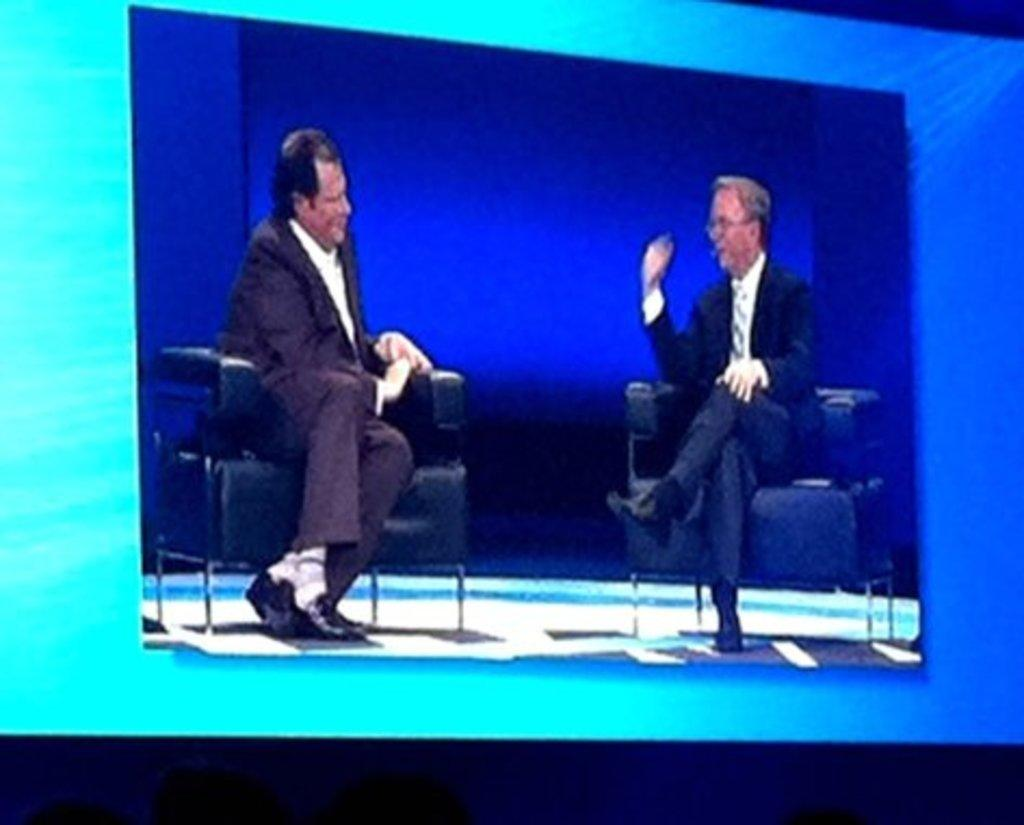What is the main object with a display in the image? There is a screen with a display in the image. How many people are present in the image? There are two men in the image. What are the two men doing in the image? The two men are sitting on chairs. What type of tank can be seen in the image? There is no tank present in the image. How many deer are visible in the image? There are no deer visible in the image. 